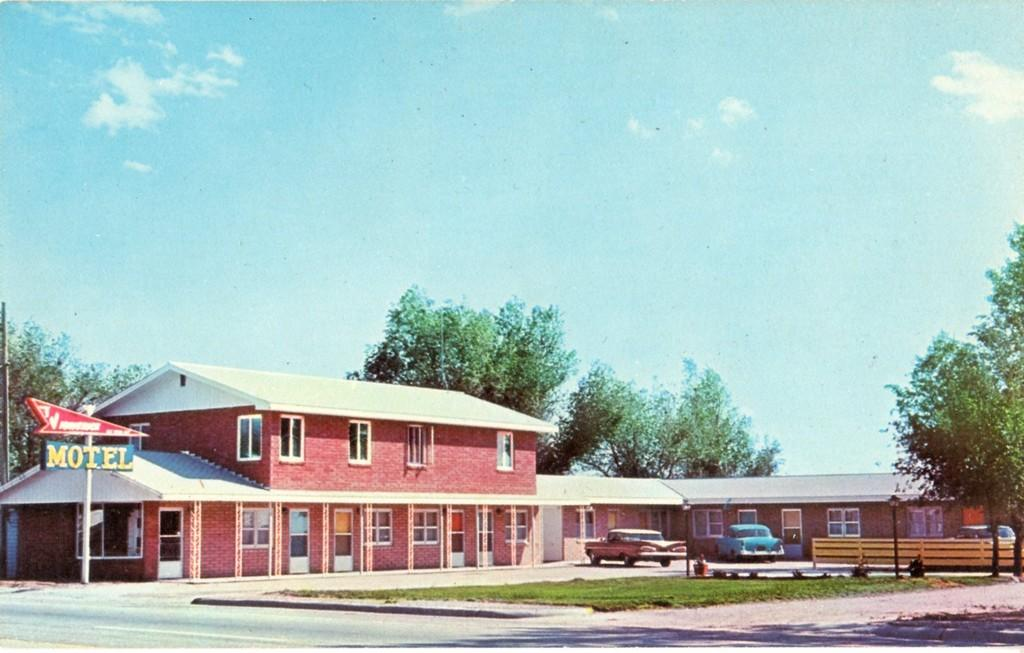Where was the image taken? The image was clicked outside. What is the main subject in the middle of the image? There is a building and trees in the middle of the image. What can be seen at the bottom of the image? There are vehicles at the bottom of the image. What is visible at the top of the image? The sky is visible at the top of the image. How many frogs are sitting on the watch in the image? There is no watch or frogs present in the image. What advice might the aunt give to the person in the image? There is no person or aunt present in the image, so it is not possible to determine what advice might be given. 